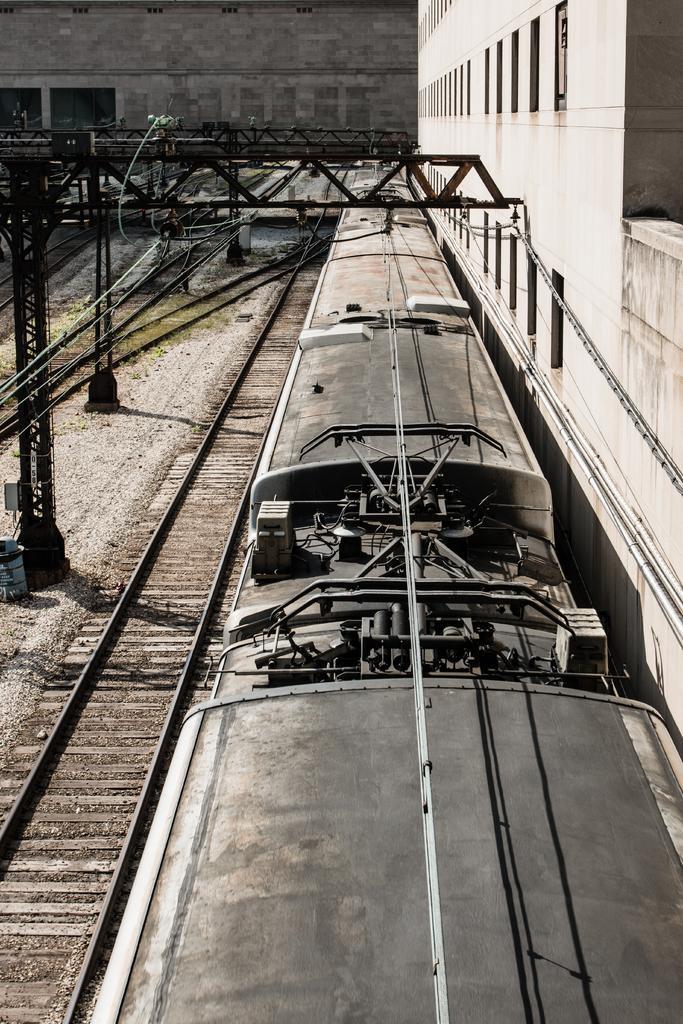Please provide a concise description of this image. In this image we can see a train on the track. There are pillars. In the background we can see buildings. 